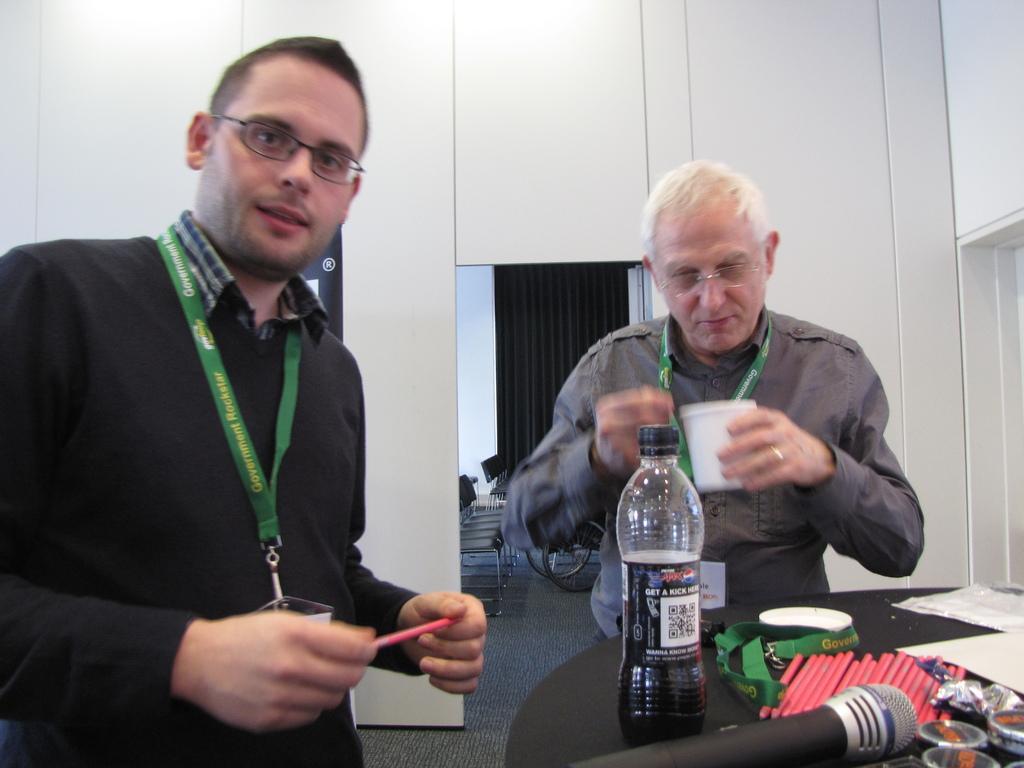In one or two sentences, can you explain what this image depicts? There are two persons standing. This is a table with a mike,green color tag,bottle,pencils and some papers on it. At background I can see few empty chairs and a wheel. 